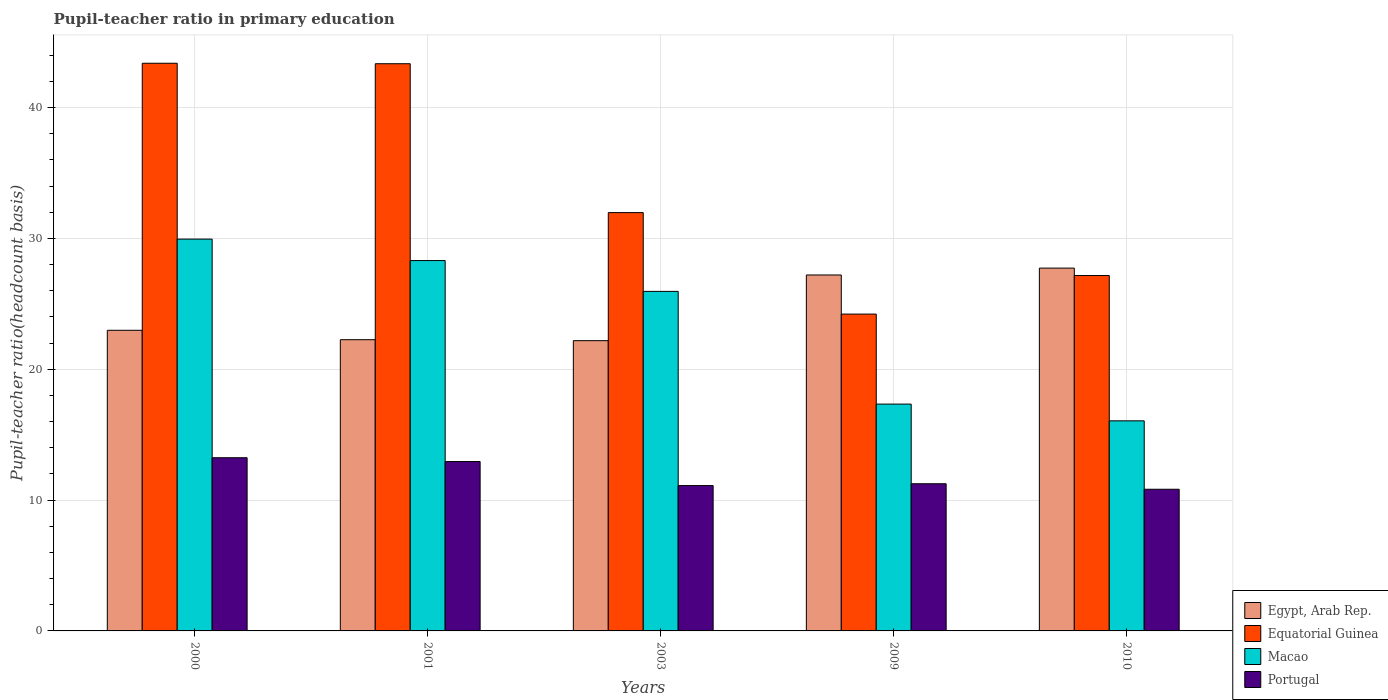Are the number of bars per tick equal to the number of legend labels?
Provide a succinct answer. Yes. How many bars are there on the 2nd tick from the right?
Make the answer very short. 4. In how many cases, is the number of bars for a given year not equal to the number of legend labels?
Ensure brevity in your answer.  0. What is the pupil-teacher ratio in primary education in Equatorial Guinea in 2010?
Make the answer very short. 27.17. Across all years, what is the maximum pupil-teacher ratio in primary education in Portugal?
Keep it short and to the point. 13.24. Across all years, what is the minimum pupil-teacher ratio in primary education in Egypt, Arab Rep.?
Offer a terse response. 22.19. In which year was the pupil-teacher ratio in primary education in Egypt, Arab Rep. maximum?
Give a very brief answer. 2010. What is the total pupil-teacher ratio in primary education in Macao in the graph?
Give a very brief answer. 117.61. What is the difference between the pupil-teacher ratio in primary education in Egypt, Arab Rep. in 2001 and that in 2009?
Provide a short and direct response. -4.95. What is the difference between the pupil-teacher ratio in primary education in Portugal in 2003 and the pupil-teacher ratio in primary education in Macao in 2009?
Give a very brief answer. -6.23. What is the average pupil-teacher ratio in primary education in Equatorial Guinea per year?
Your answer should be compact. 34.02. In the year 2000, what is the difference between the pupil-teacher ratio in primary education in Equatorial Guinea and pupil-teacher ratio in primary education in Egypt, Arab Rep.?
Your answer should be compact. 20.41. What is the ratio of the pupil-teacher ratio in primary education in Macao in 2001 to that in 2003?
Your response must be concise. 1.09. Is the pupil-teacher ratio in primary education in Egypt, Arab Rep. in 2003 less than that in 2010?
Your response must be concise. Yes. Is the difference between the pupil-teacher ratio in primary education in Equatorial Guinea in 2001 and 2009 greater than the difference between the pupil-teacher ratio in primary education in Egypt, Arab Rep. in 2001 and 2009?
Your answer should be compact. Yes. What is the difference between the highest and the second highest pupil-teacher ratio in primary education in Macao?
Your answer should be very brief. 1.64. What is the difference between the highest and the lowest pupil-teacher ratio in primary education in Portugal?
Your response must be concise. 2.41. What does the 3rd bar from the left in 2001 represents?
Make the answer very short. Macao. What does the 2nd bar from the right in 2000 represents?
Provide a short and direct response. Macao. How many years are there in the graph?
Provide a short and direct response. 5. Are the values on the major ticks of Y-axis written in scientific E-notation?
Offer a very short reply. No. Where does the legend appear in the graph?
Your answer should be compact. Bottom right. How are the legend labels stacked?
Give a very brief answer. Vertical. What is the title of the graph?
Keep it short and to the point. Pupil-teacher ratio in primary education. Does "Tanzania" appear as one of the legend labels in the graph?
Keep it short and to the point. No. What is the label or title of the Y-axis?
Keep it short and to the point. Pupil-teacher ratio(headcount basis). What is the Pupil-teacher ratio(headcount basis) of Egypt, Arab Rep. in 2000?
Offer a terse response. 22.98. What is the Pupil-teacher ratio(headcount basis) in Equatorial Guinea in 2000?
Offer a very short reply. 43.39. What is the Pupil-teacher ratio(headcount basis) of Macao in 2000?
Keep it short and to the point. 29.95. What is the Pupil-teacher ratio(headcount basis) in Portugal in 2000?
Your answer should be compact. 13.24. What is the Pupil-teacher ratio(headcount basis) of Egypt, Arab Rep. in 2001?
Your response must be concise. 22.26. What is the Pupil-teacher ratio(headcount basis) in Equatorial Guinea in 2001?
Give a very brief answer. 43.36. What is the Pupil-teacher ratio(headcount basis) in Macao in 2001?
Offer a very short reply. 28.31. What is the Pupil-teacher ratio(headcount basis) of Portugal in 2001?
Your answer should be very brief. 12.95. What is the Pupil-teacher ratio(headcount basis) in Egypt, Arab Rep. in 2003?
Your response must be concise. 22.19. What is the Pupil-teacher ratio(headcount basis) of Equatorial Guinea in 2003?
Make the answer very short. 31.98. What is the Pupil-teacher ratio(headcount basis) in Macao in 2003?
Provide a succinct answer. 25.95. What is the Pupil-teacher ratio(headcount basis) of Portugal in 2003?
Your answer should be very brief. 11.11. What is the Pupil-teacher ratio(headcount basis) of Egypt, Arab Rep. in 2009?
Provide a short and direct response. 27.21. What is the Pupil-teacher ratio(headcount basis) in Equatorial Guinea in 2009?
Give a very brief answer. 24.22. What is the Pupil-teacher ratio(headcount basis) of Macao in 2009?
Offer a very short reply. 17.34. What is the Pupil-teacher ratio(headcount basis) in Portugal in 2009?
Provide a succinct answer. 11.25. What is the Pupil-teacher ratio(headcount basis) in Egypt, Arab Rep. in 2010?
Offer a very short reply. 27.73. What is the Pupil-teacher ratio(headcount basis) of Equatorial Guinea in 2010?
Make the answer very short. 27.17. What is the Pupil-teacher ratio(headcount basis) of Macao in 2010?
Make the answer very short. 16.06. What is the Pupil-teacher ratio(headcount basis) of Portugal in 2010?
Offer a terse response. 10.83. Across all years, what is the maximum Pupil-teacher ratio(headcount basis) of Egypt, Arab Rep.?
Make the answer very short. 27.73. Across all years, what is the maximum Pupil-teacher ratio(headcount basis) of Equatorial Guinea?
Your answer should be very brief. 43.39. Across all years, what is the maximum Pupil-teacher ratio(headcount basis) in Macao?
Give a very brief answer. 29.95. Across all years, what is the maximum Pupil-teacher ratio(headcount basis) of Portugal?
Your response must be concise. 13.24. Across all years, what is the minimum Pupil-teacher ratio(headcount basis) of Egypt, Arab Rep.?
Give a very brief answer. 22.19. Across all years, what is the minimum Pupil-teacher ratio(headcount basis) of Equatorial Guinea?
Provide a short and direct response. 24.22. Across all years, what is the minimum Pupil-teacher ratio(headcount basis) of Macao?
Your response must be concise. 16.06. Across all years, what is the minimum Pupil-teacher ratio(headcount basis) in Portugal?
Provide a short and direct response. 10.83. What is the total Pupil-teacher ratio(headcount basis) of Egypt, Arab Rep. in the graph?
Make the answer very short. 122.37. What is the total Pupil-teacher ratio(headcount basis) in Equatorial Guinea in the graph?
Offer a very short reply. 170.11. What is the total Pupil-teacher ratio(headcount basis) in Macao in the graph?
Make the answer very short. 117.61. What is the total Pupil-teacher ratio(headcount basis) of Portugal in the graph?
Your answer should be compact. 59.38. What is the difference between the Pupil-teacher ratio(headcount basis) of Egypt, Arab Rep. in 2000 and that in 2001?
Ensure brevity in your answer.  0.72. What is the difference between the Pupil-teacher ratio(headcount basis) of Equatorial Guinea in 2000 and that in 2001?
Keep it short and to the point. 0.04. What is the difference between the Pupil-teacher ratio(headcount basis) of Macao in 2000 and that in 2001?
Your answer should be compact. 1.64. What is the difference between the Pupil-teacher ratio(headcount basis) in Portugal in 2000 and that in 2001?
Offer a terse response. 0.29. What is the difference between the Pupil-teacher ratio(headcount basis) of Egypt, Arab Rep. in 2000 and that in 2003?
Keep it short and to the point. 0.79. What is the difference between the Pupil-teacher ratio(headcount basis) in Equatorial Guinea in 2000 and that in 2003?
Make the answer very short. 11.42. What is the difference between the Pupil-teacher ratio(headcount basis) of Macao in 2000 and that in 2003?
Make the answer very short. 4. What is the difference between the Pupil-teacher ratio(headcount basis) in Portugal in 2000 and that in 2003?
Keep it short and to the point. 2.13. What is the difference between the Pupil-teacher ratio(headcount basis) of Egypt, Arab Rep. in 2000 and that in 2009?
Make the answer very short. -4.23. What is the difference between the Pupil-teacher ratio(headcount basis) in Equatorial Guinea in 2000 and that in 2009?
Offer a terse response. 19.17. What is the difference between the Pupil-teacher ratio(headcount basis) in Macao in 2000 and that in 2009?
Make the answer very short. 12.61. What is the difference between the Pupil-teacher ratio(headcount basis) in Portugal in 2000 and that in 2009?
Give a very brief answer. 1.99. What is the difference between the Pupil-teacher ratio(headcount basis) in Egypt, Arab Rep. in 2000 and that in 2010?
Your response must be concise. -4.75. What is the difference between the Pupil-teacher ratio(headcount basis) of Equatorial Guinea in 2000 and that in 2010?
Keep it short and to the point. 16.23. What is the difference between the Pupil-teacher ratio(headcount basis) of Macao in 2000 and that in 2010?
Ensure brevity in your answer.  13.89. What is the difference between the Pupil-teacher ratio(headcount basis) in Portugal in 2000 and that in 2010?
Make the answer very short. 2.41. What is the difference between the Pupil-teacher ratio(headcount basis) in Egypt, Arab Rep. in 2001 and that in 2003?
Provide a short and direct response. 0.07. What is the difference between the Pupil-teacher ratio(headcount basis) in Equatorial Guinea in 2001 and that in 2003?
Offer a terse response. 11.38. What is the difference between the Pupil-teacher ratio(headcount basis) in Macao in 2001 and that in 2003?
Give a very brief answer. 2.35. What is the difference between the Pupil-teacher ratio(headcount basis) of Portugal in 2001 and that in 2003?
Offer a very short reply. 1.84. What is the difference between the Pupil-teacher ratio(headcount basis) in Egypt, Arab Rep. in 2001 and that in 2009?
Your answer should be very brief. -4.95. What is the difference between the Pupil-teacher ratio(headcount basis) of Equatorial Guinea in 2001 and that in 2009?
Offer a terse response. 19.14. What is the difference between the Pupil-teacher ratio(headcount basis) of Macao in 2001 and that in 2009?
Provide a short and direct response. 10.97. What is the difference between the Pupil-teacher ratio(headcount basis) in Portugal in 2001 and that in 2009?
Offer a terse response. 1.7. What is the difference between the Pupil-teacher ratio(headcount basis) of Egypt, Arab Rep. in 2001 and that in 2010?
Your answer should be very brief. -5.47. What is the difference between the Pupil-teacher ratio(headcount basis) in Equatorial Guinea in 2001 and that in 2010?
Provide a short and direct response. 16.19. What is the difference between the Pupil-teacher ratio(headcount basis) of Macao in 2001 and that in 2010?
Your response must be concise. 12.25. What is the difference between the Pupil-teacher ratio(headcount basis) in Portugal in 2001 and that in 2010?
Provide a succinct answer. 2.12. What is the difference between the Pupil-teacher ratio(headcount basis) of Egypt, Arab Rep. in 2003 and that in 2009?
Make the answer very short. -5.02. What is the difference between the Pupil-teacher ratio(headcount basis) in Equatorial Guinea in 2003 and that in 2009?
Keep it short and to the point. 7.76. What is the difference between the Pupil-teacher ratio(headcount basis) of Macao in 2003 and that in 2009?
Your answer should be compact. 8.62. What is the difference between the Pupil-teacher ratio(headcount basis) in Portugal in 2003 and that in 2009?
Your answer should be compact. -0.14. What is the difference between the Pupil-teacher ratio(headcount basis) in Egypt, Arab Rep. in 2003 and that in 2010?
Your answer should be compact. -5.55. What is the difference between the Pupil-teacher ratio(headcount basis) of Equatorial Guinea in 2003 and that in 2010?
Provide a succinct answer. 4.81. What is the difference between the Pupil-teacher ratio(headcount basis) in Macao in 2003 and that in 2010?
Provide a short and direct response. 9.9. What is the difference between the Pupil-teacher ratio(headcount basis) in Portugal in 2003 and that in 2010?
Your answer should be compact. 0.28. What is the difference between the Pupil-teacher ratio(headcount basis) of Egypt, Arab Rep. in 2009 and that in 2010?
Offer a very short reply. -0.53. What is the difference between the Pupil-teacher ratio(headcount basis) in Equatorial Guinea in 2009 and that in 2010?
Make the answer very short. -2.95. What is the difference between the Pupil-teacher ratio(headcount basis) of Macao in 2009 and that in 2010?
Your answer should be very brief. 1.28. What is the difference between the Pupil-teacher ratio(headcount basis) of Portugal in 2009 and that in 2010?
Provide a short and direct response. 0.42. What is the difference between the Pupil-teacher ratio(headcount basis) of Egypt, Arab Rep. in 2000 and the Pupil-teacher ratio(headcount basis) of Equatorial Guinea in 2001?
Keep it short and to the point. -20.38. What is the difference between the Pupil-teacher ratio(headcount basis) of Egypt, Arab Rep. in 2000 and the Pupil-teacher ratio(headcount basis) of Macao in 2001?
Keep it short and to the point. -5.33. What is the difference between the Pupil-teacher ratio(headcount basis) in Egypt, Arab Rep. in 2000 and the Pupil-teacher ratio(headcount basis) in Portugal in 2001?
Offer a very short reply. 10.03. What is the difference between the Pupil-teacher ratio(headcount basis) in Equatorial Guinea in 2000 and the Pupil-teacher ratio(headcount basis) in Macao in 2001?
Offer a very short reply. 15.08. What is the difference between the Pupil-teacher ratio(headcount basis) of Equatorial Guinea in 2000 and the Pupil-teacher ratio(headcount basis) of Portugal in 2001?
Provide a short and direct response. 30.45. What is the difference between the Pupil-teacher ratio(headcount basis) of Macao in 2000 and the Pupil-teacher ratio(headcount basis) of Portugal in 2001?
Ensure brevity in your answer.  17. What is the difference between the Pupil-teacher ratio(headcount basis) of Egypt, Arab Rep. in 2000 and the Pupil-teacher ratio(headcount basis) of Equatorial Guinea in 2003?
Your answer should be very brief. -9. What is the difference between the Pupil-teacher ratio(headcount basis) of Egypt, Arab Rep. in 2000 and the Pupil-teacher ratio(headcount basis) of Macao in 2003?
Offer a very short reply. -2.97. What is the difference between the Pupil-teacher ratio(headcount basis) of Egypt, Arab Rep. in 2000 and the Pupil-teacher ratio(headcount basis) of Portugal in 2003?
Provide a short and direct response. 11.87. What is the difference between the Pupil-teacher ratio(headcount basis) of Equatorial Guinea in 2000 and the Pupil-teacher ratio(headcount basis) of Macao in 2003?
Your answer should be compact. 17.44. What is the difference between the Pupil-teacher ratio(headcount basis) of Equatorial Guinea in 2000 and the Pupil-teacher ratio(headcount basis) of Portugal in 2003?
Ensure brevity in your answer.  32.28. What is the difference between the Pupil-teacher ratio(headcount basis) in Macao in 2000 and the Pupil-teacher ratio(headcount basis) in Portugal in 2003?
Make the answer very short. 18.84. What is the difference between the Pupil-teacher ratio(headcount basis) of Egypt, Arab Rep. in 2000 and the Pupil-teacher ratio(headcount basis) of Equatorial Guinea in 2009?
Your response must be concise. -1.24. What is the difference between the Pupil-teacher ratio(headcount basis) in Egypt, Arab Rep. in 2000 and the Pupil-teacher ratio(headcount basis) in Macao in 2009?
Offer a very short reply. 5.64. What is the difference between the Pupil-teacher ratio(headcount basis) of Egypt, Arab Rep. in 2000 and the Pupil-teacher ratio(headcount basis) of Portugal in 2009?
Keep it short and to the point. 11.73. What is the difference between the Pupil-teacher ratio(headcount basis) in Equatorial Guinea in 2000 and the Pupil-teacher ratio(headcount basis) in Macao in 2009?
Your answer should be compact. 26.05. What is the difference between the Pupil-teacher ratio(headcount basis) in Equatorial Guinea in 2000 and the Pupil-teacher ratio(headcount basis) in Portugal in 2009?
Make the answer very short. 32.14. What is the difference between the Pupil-teacher ratio(headcount basis) in Macao in 2000 and the Pupil-teacher ratio(headcount basis) in Portugal in 2009?
Offer a very short reply. 18.7. What is the difference between the Pupil-teacher ratio(headcount basis) in Egypt, Arab Rep. in 2000 and the Pupil-teacher ratio(headcount basis) in Equatorial Guinea in 2010?
Make the answer very short. -4.19. What is the difference between the Pupil-teacher ratio(headcount basis) in Egypt, Arab Rep. in 2000 and the Pupil-teacher ratio(headcount basis) in Macao in 2010?
Provide a succinct answer. 6.92. What is the difference between the Pupil-teacher ratio(headcount basis) of Egypt, Arab Rep. in 2000 and the Pupil-teacher ratio(headcount basis) of Portugal in 2010?
Your answer should be very brief. 12.15. What is the difference between the Pupil-teacher ratio(headcount basis) of Equatorial Guinea in 2000 and the Pupil-teacher ratio(headcount basis) of Macao in 2010?
Your answer should be very brief. 27.33. What is the difference between the Pupil-teacher ratio(headcount basis) in Equatorial Guinea in 2000 and the Pupil-teacher ratio(headcount basis) in Portugal in 2010?
Ensure brevity in your answer.  32.56. What is the difference between the Pupil-teacher ratio(headcount basis) in Macao in 2000 and the Pupil-teacher ratio(headcount basis) in Portugal in 2010?
Provide a short and direct response. 19.12. What is the difference between the Pupil-teacher ratio(headcount basis) in Egypt, Arab Rep. in 2001 and the Pupil-teacher ratio(headcount basis) in Equatorial Guinea in 2003?
Offer a very short reply. -9.72. What is the difference between the Pupil-teacher ratio(headcount basis) of Egypt, Arab Rep. in 2001 and the Pupil-teacher ratio(headcount basis) of Macao in 2003?
Provide a succinct answer. -3.69. What is the difference between the Pupil-teacher ratio(headcount basis) in Egypt, Arab Rep. in 2001 and the Pupil-teacher ratio(headcount basis) in Portugal in 2003?
Give a very brief answer. 11.15. What is the difference between the Pupil-teacher ratio(headcount basis) of Equatorial Guinea in 2001 and the Pupil-teacher ratio(headcount basis) of Macao in 2003?
Offer a very short reply. 17.4. What is the difference between the Pupil-teacher ratio(headcount basis) of Equatorial Guinea in 2001 and the Pupil-teacher ratio(headcount basis) of Portugal in 2003?
Offer a terse response. 32.25. What is the difference between the Pupil-teacher ratio(headcount basis) of Macao in 2001 and the Pupil-teacher ratio(headcount basis) of Portugal in 2003?
Your response must be concise. 17.2. What is the difference between the Pupil-teacher ratio(headcount basis) of Egypt, Arab Rep. in 2001 and the Pupil-teacher ratio(headcount basis) of Equatorial Guinea in 2009?
Offer a terse response. -1.96. What is the difference between the Pupil-teacher ratio(headcount basis) of Egypt, Arab Rep. in 2001 and the Pupil-teacher ratio(headcount basis) of Macao in 2009?
Offer a terse response. 4.92. What is the difference between the Pupil-teacher ratio(headcount basis) in Egypt, Arab Rep. in 2001 and the Pupil-teacher ratio(headcount basis) in Portugal in 2009?
Your answer should be very brief. 11.01. What is the difference between the Pupil-teacher ratio(headcount basis) in Equatorial Guinea in 2001 and the Pupil-teacher ratio(headcount basis) in Macao in 2009?
Give a very brief answer. 26.02. What is the difference between the Pupil-teacher ratio(headcount basis) in Equatorial Guinea in 2001 and the Pupil-teacher ratio(headcount basis) in Portugal in 2009?
Your answer should be compact. 32.11. What is the difference between the Pupil-teacher ratio(headcount basis) in Macao in 2001 and the Pupil-teacher ratio(headcount basis) in Portugal in 2009?
Your answer should be very brief. 17.06. What is the difference between the Pupil-teacher ratio(headcount basis) of Egypt, Arab Rep. in 2001 and the Pupil-teacher ratio(headcount basis) of Equatorial Guinea in 2010?
Your response must be concise. -4.91. What is the difference between the Pupil-teacher ratio(headcount basis) in Egypt, Arab Rep. in 2001 and the Pupil-teacher ratio(headcount basis) in Macao in 2010?
Provide a short and direct response. 6.2. What is the difference between the Pupil-teacher ratio(headcount basis) of Egypt, Arab Rep. in 2001 and the Pupil-teacher ratio(headcount basis) of Portugal in 2010?
Your answer should be compact. 11.43. What is the difference between the Pupil-teacher ratio(headcount basis) of Equatorial Guinea in 2001 and the Pupil-teacher ratio(headcount basis) of Macao in 2010?
Your answer should be compact. 27.3. What is the difference between the Pupil-teacher ratio(headcount basis) in Equatorial Guinea in 2001 and the Pupil-teacher ratio(headcount basis) in Portugal in 2010?
Give a very brief answer. 32.53. What is the difference between the Pupil-teacher ratio(headcount basis) in Macao in 2001 and the Pupil-teacher ratio(headcount basis) in Portugal in 2010?
Give a very brief answer. 17.48. What is the difference between the Pupil-teacher ratio(headcount basis) in Egypt, Arab Rep. in 2003 and the Pupil-teacher ratio(headcount basis) in Equatorial Guinea in 2009?
Give a very brief answer. -2.03. What is the difference between the Pupil-teacher ratio(headcount basis) of Egypt, Arab Rep. in 2003 and the Pupil-teacher ratio(headcount basis) of Macao in 2009?
Provide a succinct answer. 4.85. What is the difference between the Pupil-teacher ratio(headcount basis) of Egypt, Arab Rep. in 2003 and the Pupil-teacher ratio(headcount basis) of Portugal in 2009?
Your answer should be very brief. 10.94. What is the difference between the Pupil-teacher ratio(headcount basis) of Equatorial Guinea in 2003 and the Pupil-teacher ratio(headcount basis) of Macao in 2009?
Provide a short and direct response. 14.64. What is the difference between the Pupil-teacher ratio(headcount basis) in Equatorial Guinea in 2003 and the Pupil-teacher ratio(headcount basis) in Portugal in 2009?
Your answer should be very brief. 20.73. What is the difference between the Pupil-teacher ratio(headcount basis) in Macao in 2003 and the Pupil-teacher ratio(headcount basis) in Portugal in 2009?
Ensure brevity in your answer.  14.71. What is the difference between the Pupil-teacher ratio(headcount basis) of Egypt, Arab Rep. in 2003 and the Pupil-teacher ratio(headcount basis) of Equatorial Guinea in 2010?
Offer a very short reply. -4.98. What is the difference between the Pupil-teacher ratio(headcount basis) of Egypt, Arab Rep. in 2003 and the Pupil-teacher ratio(headcount basis) of Macao in 2010?
Offer a very short reply. 6.13. What is the difference between the Pupil-teacher ratio(headcount basis) in Egypt, Arab Rep. in 2003 and the Pupil-teacher ratio(headcount basis) in Portugal in 2010?
Keep it short and to the point. 11.36. What is the difference between the Pupil-teacher ratio(headcount basis) of Equatorial Guinea in 2003 and the Pupil-teacher ratio(headcount basis) of Macao in 2010?
Offer a very short reply. 15.92. What is the difference between the Pupil-teacher ratio(headcount basis) in Equatorial Guinea in 2003 and the Pupil-teacher ratio(headcount basis) in Portugal in 2010?
Offer a terse response. 21.15. What is the difference between the Pupil-teacher ratio(headcount basis) in Macao in 2003 and the Pupil-teacher ratio(headcount basis) in Portugal in 2010?
Keep it short and to the point. 15.13. What is the difference between the Pupil-teacher ratio(headcount basis) in Egypt, Arab Rep. in 2009 and the Pupil-teacher ratio(headcount basis) in Equatorial Guinea in 2010?
Offer a terse response. 0.04. What is the difference between the Pupil-teacher ratio(headcount basis) in Egypt, Arab Rep. in 2009 and the Pupil-teacher ratio(headcount basis) in Macao in 2010?
Ensure brevity in your answer.  11.15. What is the difference between the Pupil-teacher ratio(headcount basis) of Egypt, Arab Rep. in 2009 and the Pupil-teacher ratio(headcount basis) of Portugal in 2010?
Ensure brevity in your answer.  16.38. What is the difference between the Pupil-teacher ratio(headcount basis) of Equatorial Guinea in 2009 and the Pupil-teacher ratio(headcount basis) of Macao in 2010?
Make the answer very short. 8.16. What is the difference between the Pupil-teacher ratio(headcount basis) of Equatorial Guinea in 2009 and the Pupil-teacher ratio(headcount basis) of Portugal in 2010?
Your answer should be compact. 13.39. What is the difference between the Pupil-teacher ratio(headcount basis) of Macao in 2009 and the Pupil-teacher ratio(headcount basis) of Portugal in 2010?
Your answer should be compact. 6.51. What is the average Pupil-teacher ratio(headcount basis) in Egypt, Arab Rep. per year?
Offer a very short reply. 24.47. What is the average Pupil-teacher ratio(headcount basis) of Equatorial Guinea per year?
Make the answer very short. 34.02. What is the average Pupil-teacher ratio(headcount basis) of Macao per year?
Offer a terse response. 23.52. What is the average Pupil-teacher ratio(headcount basis) in Portugal per year?
Offer a very short reply. 11.88. In the year 2000, what is the difference between the Pupil-teacher ratio(headcount basis) of Egypt, Arab Rep. and Pupil-teacher ratio(headcount basis) of Equatorial Guinea?
Your answer should be compact. -20.41. In the year 2000, what is the difference between the Pupil-teacher ratio(headcount basis) in Egypt, Arab Rep. and Pupil-teacher ratio(headcount basis) in Macao?
Keep it short and to the point. -6.97. In the year 2000, what is the difference between the Pupil-teacher ratio(headcount basis) in Egypt, Arab Rep. and Pupil-teacher ratio(headcount basis) in Portugal?
Give a very brief answer. 9.74. In the year 2000, what is the difference between the Pupil-teacher ratio(headcount basis) in Equatorial Guinea and Pupil-teacher ratio(headcount basis) in Macao?
Offer a terse response. 13.44. In the year 2000, what is the difference between the Pupil-teacher ratio(headcount basis) in Equatorial Guinea and Pupil-teacher ratio(headcount basis) in Portugal?
Offer a terse response. 30.15. In the year 2000, what is the difference between the Pupil-teacher ratio(headcount basis) in Macao and Pupil-teacher ratio(headcount basis) in Portugal?
Keep it short and to the point. 16.71. In the year 2001, what is the difference between the Pupil-teacher ratio(headcount basis) of Egypt, Arab Rep. and Pupil-teacher ratio(headcount basis) of Equatorial Guinea?
Offer a very short reply. -21.1. In the year 2001, what is the difference between the Pupil-teacher ratio(headcount basis) of Egypt, Arab Rep. and Pupil-teacher ratio(headcount basis) of Macao?
Offer a terse response. -6.05. In the year 2001, what is the difference between the Pupil-teacher ratio(headcount basis) of Egypt, Arab Rep. and Pupil-teacher ratio(headcount basis) of Portugal?
Provide a short and direct response. 9.31. In the year 2001, what is the difference between the Pupil-teacher ratio(headcount basis) of Equatorial Guinea and Pupil-teacher ratio(headcount basis) of Macao?
Your answer should be compact. 15.05. In the year 2001, what is the difference between the Pupil-teacher ratio(headcount basis) of Equatorial Guinea and Pupil-teacher ratio(headcount basis) of Portugal?
Make the answer very short. 30.41. In the year 2001, what is the difference between the Pupil-teacher ratio(headcount basis) of Macao and Pupil-teacher ratio(headcount basis) of Portugal?
Provide a succinct answer. 15.36. In the year 2003, what is the difference between the Pupil-teacher ratio(headcount basis) of Egypt, Arab Rep. and Pupil-teacher ratio(headcount basis) of Equatorial Guinea?
Your response must be concise. -9.79. In the year 2003, what is the difference between the Pupil-teacher ratio(headcount basis) of Egypt, Arab Rep. and Pupil-teacher ratio(headcount basis) of Macao?
Give a very brief answer. -3.77. In the year 2003, what is the difference between the Pupil-teacher ratio(headcount basis) in Egypt, Arab Rep. and Pupil-teacher ratio(headcount basis) in Portugal?
Provide a succinct answer. 11.08. In the year 2003, what is the difference between the Pupil-teacher ratio(headcount basis) in Equatorial Guinea and Pupil-teacher ratio(headcount basis) in Macao?
Your answer should be compact. 6.02. In the year 2003, what is the difference between the Pupil-teacher ratio(headcount basis) in Equatorial Guinea and Pupil-teacher ratio(headcount basis) in Portugal?
Provide a succinct answer. 20.87. In the year 2003, what is the difference between the Pupil-teacher ratio(headcount basis) in Macao and Pupil-teacher ratio(headcount basis) in Portugal?
Offer a terse response. 14.84. In the year 2009, what is the difference between the Pupil-teacher ratio(headcount basis) of Egypt, Arab Rep. and Pupil-teacher ratio(headcount basis) of Equatorial Guinea?
Ensure brevity in your answer.  2.99. In the year 2009, what is the difference between the Pupil-teacher ratio(headcount basis) in Egypt, Arab Rep. and Pupil-teacher ratio(headcount basis) in Macao?
Give a very brief answer. 9.87. In the year 2009, what is the difference between the Pupil-teacher ratio(headcount basis) of Egypt, Arab Rep. and Pupil-teacher ratio(headcount basis) of Portugal?
Your answer should be compact. 15.96. In the year 2009, what is the difference between the Pupil-teacher ratio(headcount basis) of Equatorial Guinea and Pupil-teacher ratio(headcount basis) of Macao?
Keep it short and to the point. 6.88. In the year 2009, what is the difference between the Pupil-teacher ratio(headcount basis) of Equatorial Guinea and Pupil-teacher ratio(headcount basis) of Portugal?
Offer a very short reply. 12.97. In the year 2009, what is the difference between the Pupil-teacher ratio(headcount basis) in Macao and Pupil-teacher ratio(headcount basis) in Portugal?
Provide a short and direct response. 6.09. In the year 2010, what is the difference between the Pupil-teacher ratio(headcount basis) of Egypt, Arab Rep. and Pupil-teacher ratio(headcount basis) of Equatorial Guinea?
Your answer should be very brief. 0.57. In the year 2010, what is the difference between the Pupil-teacher ratio(headcount basis) in Egypt, Arab Rep. and Pupil-teacher ratio(headcount basis) in Macao?
Your answer should be very brief. 11.67. In the year 2010, what is the difference between the Pupil-teacher ratio(headcount basis) of Egypt, Arab Rep. and Pupil-teacher ratio(headcount basis) of Portugal?
Make the answer very short. 16.91. In the year 2010, what is the difference between the Pupil-teacher ratio(headcount basis) in Equatorial Guinea and Pupil-teacher ratio(headcount basis) in Macao?
Your answer should be compact. 11.11. In the year 2010, what is the difference between the Pupil-teacher ratio(headcount basis) of Equatorial Guinea and Pupil-teacher ratio(headcount basis) of Portugal?
Offer a very short reply. 16.34. In the year 2010, what is the difference between the Pupil-teacher ratio(headcount basis) of Macao and Pupil-teacher ratio(headcount basis) of Portugal?
Keep it short and to the point. 5.23. What is the ratio of the Pupil-teacher ratio(headcount basis) of Egypt, Arab Rep. in 2000 to that in 2001?
Provide a short and direct response. 1.03. What is the ratio of the Pupil-teacher ratio(headcount basis) in Macao in 2000 to that in 2001?
Provide a succinct answer. 1.06. What is the ratio of the Pupil-teacher ratio(headcount basis) of Portugal in 2000 to that in 2001?
Offer a very short reply. 1.02. What is the ratio of the Pupil-teacher ratio(headcount basis) in Egypt, Arab Rep. in 2000 to that in 2003?
Provide a succinct answer. 1.04. What is the ratio of the Pupil-teacher ratio(headcount basis) of Equatorial Guinea in 2000 to that in 2003?
Your answer should be very brief. 1.36. What is the ratio of the Pupil-teacher ratio(headcount basis) of Macao in 2000 to that in 2003?
Offer a very short reply. 1.15. What is the ratio of the Pupil-teacher ratio(headcount basis) in Portugal in 2000 to that in 2003?
Your answer should be very brief. 1.19. What is the ratio of the Pupil-teacher ratio(headcount basis) in Egypt, Arab Rep. in 2000 to that in 2009?
Give a very brief answer. 0.84. What is the ratio of the Pupil-teacher ratio(headcount basis) in Equatorial Guinea in 2000 to that in 2009?
Give a very brief answer. 1.79. What is the ratio of the Pupil-teacher ratio(headcount basis) in Macao in 2000 to that in 2009?
Make the answer very short. 1.73. What is the ratio of the Pupil-teacher ratio(headcount basis) of Portugal in 2000 to that in 2009?
Offer a terse response. 1.18. What is the ratio of the Pupil-teacher ratio(headcount basis) in Egypt, Arab Rep. in 2000 to that in 2010?
Give a very brief answer. 0.83. What is the ratio of the Pupil-teacher ratio(headcount basis) in Equatorial Guinea in 2000 to that in 2010?
Give a very brief answer. 1.6. What is the ratio of the Pupil-teacher ratio(headcount basis) of Macao in 2000 to that in 2010?
Offer a very short reply. 1.86. What is the ratio of the Pupil-teacher ratio(headcount basis) in Portugal in 2000 to that in 2010?
Keep it short and to the point. 1.22. What is the ratio of the Pupil-teacher ratio(headcount basis) of Egypt, Arab Rep. in 2001 to that in 2003?
Make the answer very short. 1. What is the ratio of the Pupil-teacher ratio(headcount basis) in Equatorial Guinea in 2001 to that in 2003?
Make the answer very short. 1.36. What is the ratio of the Pupil-teacher ratio(headcount basis) of Macao in 2001 to that in 2003?
Offer a terse response. 1.09. What is the ratio of the Pupil-teacher ratio(headcount basis) of Portugal in 2001 to that in 2003?
Ensure brevity in your answer.  1.17. What is the ratio of the Pupil-teacher ratio(headcount basis) in Egypt, Arab Rep. in 2001 to that in 2009?
Your response must be concise. 0.82. What is the ratio of the Pupil-teacher ratio(headcount basis) in Equatorial Guinea in 2001 to that in 2009?
Provide a succinct answer. 1.79. What is the ratio of the Pupil-teacher ratio(headcount basis) of Macao in 2001 to that in 2009?
Provide a succinct answer. 1.63. What is the ratio of the Pupil-teacher ratio(headcount basis) of Portugal in 2001 to that in 2009?
Provide a short and direct response. 1.15. What is the ratio of the Pupil-teacher ratio(headcount basis) in Egypt, Arab Rep. in 2001 to that in 2010?
Give a very brief answer. 0.8. What is the ratio of the Pupil-teacher ratio(headcount basis) of Equatorial Guinea in 2001 to that in 2010?
Your answer should be very brief. 1.6. What is the ratio of the Pupil-teacher ratio(headcount basis) of Macao in 2001 to that in 2010?
Keep it short and to the point. 1.76. What is the ratio of the Pupil-teacher ratio(headcount basis) of Portugal in 2001 to that in 2010?
Your response must be concise. 1.2. What is the ratio of the Pupil-teacher ratio(headcount basis) in Egypt, Arab Rep. in 2003 to that in 2009?
Your answer should be very brief. 0.82. What is the ratio of the Pupil-teacher ratio(headcount basis) in Equatorial Guinea in 2003 to that in 2009?
Ensure brevity in your answer.  1.32. What is the ratio of the Pupil-teacher ratio(headcount basis) of Macao in 2003 to that in 2009?
Your response must be concise. 1.5. What is the ratio of the Pupil-teacher ratio(headcount basis) of Portugal in 2003 to that in 2009?
Ensure brevity in your answer.  0.99. What is the ratio of the Pupil-teacher ratio(headcount basis) of Equatorial Guinea in 2003 to that in 2010?
Offer a very short reply. 1.18. What is the ratio of the Pupil-teacher ratio(headcount basis) in Macao in 2003 to that in 2010?
Provide a succinct answer. 1.62. What is the ratio of the Pupil-teacher ratio(headcount basis) in Egypt, Arab Rep. in 2009 to that in 2010?
Make the answer very short. 0.98. What is the ratio of the Pupil-teacher ratio(headcount basis) in Equatorial Guinea in 2009 to that in 2010?
Ensure brevity in your answer.  0.89. What is the ratio of the Pupil-teacher ratio(headcount basis) of Macao in 2009 to that in 2010?
Your answer should be very brief. 1.08. What is the ratio of the Pupil-teacher ratio(headcount basis) in Portugal in 2009 to that in 2010?
Make the answer very short. 1.04. What is the difference between the highest and the second highest Pupil-teacher ratio(headcount basis) of Egypt, Arab Rep.?
Ensure brevity in your answer.  0.53. What is the difference between the highest and the second highest Pupil-teacher ratio(headcount basis) in Equatorial Guinea?
Offer a very short reply. 0.04. What is the difference between the highest and the second highest Pupil-teacher ratio(headcount basis) of Macao?
Give a very brief answer. 1.64. What is the difference between the highest and the second highest Pupil-teacher ratio(headcount basis) in Portugal?
Offer a terse response. 0.29. What is the difference between the highest and the lowest Pupil-teacher ratio(headcount basis) of Egypt, Arab Rep.?
Provide a short and direct response. 5.55. What is the difference between the highest and the lowest Pupil-teacher ratio(headcount basis) in Equatorial Guinea?
Make the answer very short. 19.17. What is the difference between the highest and the lowest Pupil-teacher ratio(headcount basis) in Macao?
Your response must be concise. 13.89. What is the difference between the highest and the lowest Pupil-teacher ratio(headcount basis) in Portugal?
Keep it short and to the point. 2.41. 